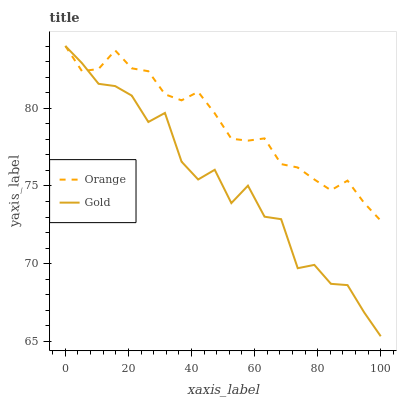Does Gold have the minimum area under the curve?
Answer yes or no. Yes. Does Orange have the maximum area under the curve?
Answer yes or no. Yes. Does Gold have the maximum area under the curve?
Answer yes or no. No. Is Orange the smoothest?
Answer yes or no. Yes. Is Gold the roughest?
Answer yes or no. Yes. Is Gold the smoothest?
Answer yes or no. No. Does Gold have the highest value?
Answer yes or no. Yes. Does Gold intersect Orange?
Answer yes or no. Yes. Is Gold less than Orange?
Answer yes or no. No. Is Gold greater than Orange?
Answer yes or no. No. 